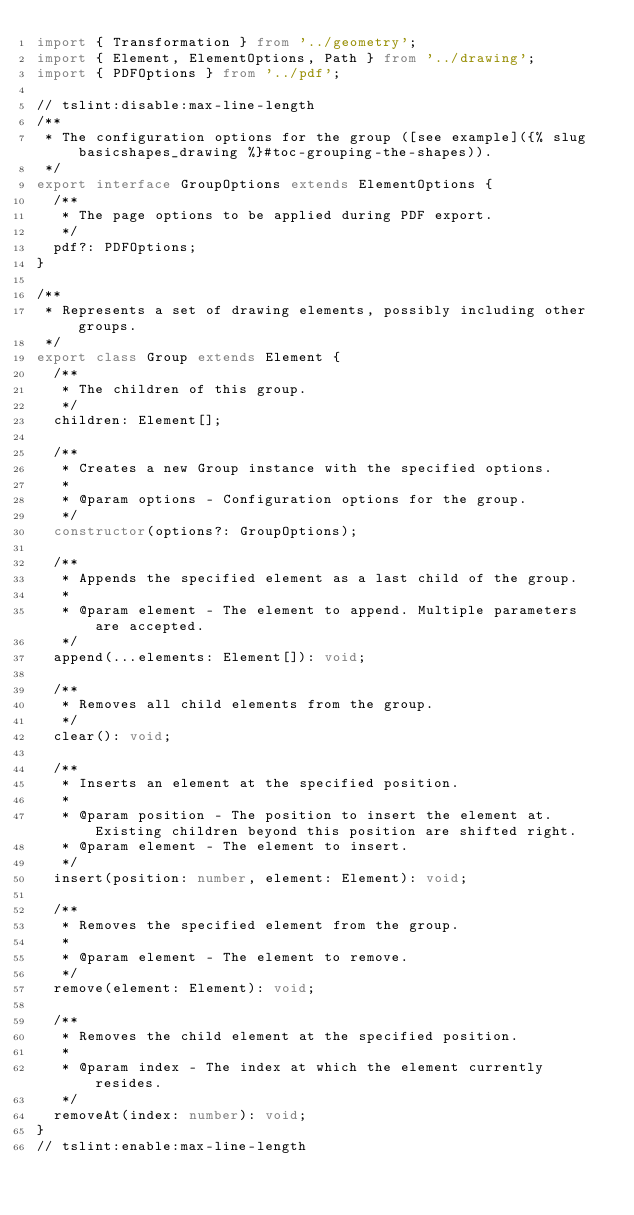<code> <loc_0><loc_0><loc_500><loc_500><_TypeScript_>import { Transformation } from '../geometry';
import { Element, ElementOptions, Path } from '../drawing';
import { PDFOptions } from '../pdf';

// tslint:disable:max-line-length
/**
 * The configuration options for the group ([see example]({% slug basicshapes_drawing %}#toc-grouping-the-shapes)).
 */
export interface GroupOptions extends ElementOptions {
  /**
   * The page options to be applied during PDF export.
   */
  pdf?: PDFOptions;
}

/**
 * Represents a set of drawing elements, possibly including other groups.
 */
export class Group extends Element {
  /**
   * The children of this group.
   */
  children: Element[];

  /**
   * Creates a new Group instance with the specified options.
   *
   * @param options - Configuration options for the group.
   */
  constructor(options?: GroupOptions);

  /**
   * Appends the specified element as a last child of the group.
   *
   * @param element - The element to append. Multiple parameters are accepted.
   */
  append(...elements: Element[]): void;

  /**
   * Removes all child elements from the group.
   */
  clear(): void;

  /**
   * Inserts an element at the specified position.
   *
   * @param position - The position to insert the element at. Existing children beyond this position are shifted right.
   * @param element - The element to insert.
   */
  insert(position: number, element: Element): void;

  /**
   * Removes the specified element from the group.
   *
   * @param element - The element to remove.
   */
  remove(element: Element): void;

  /**
   * Removes the child element at the specified position.
   *
   * @param index - The index at which the element currently resides.
   */
  removeAt(index: number): void;
}
// tslint:enable:max-line-length
</code> 